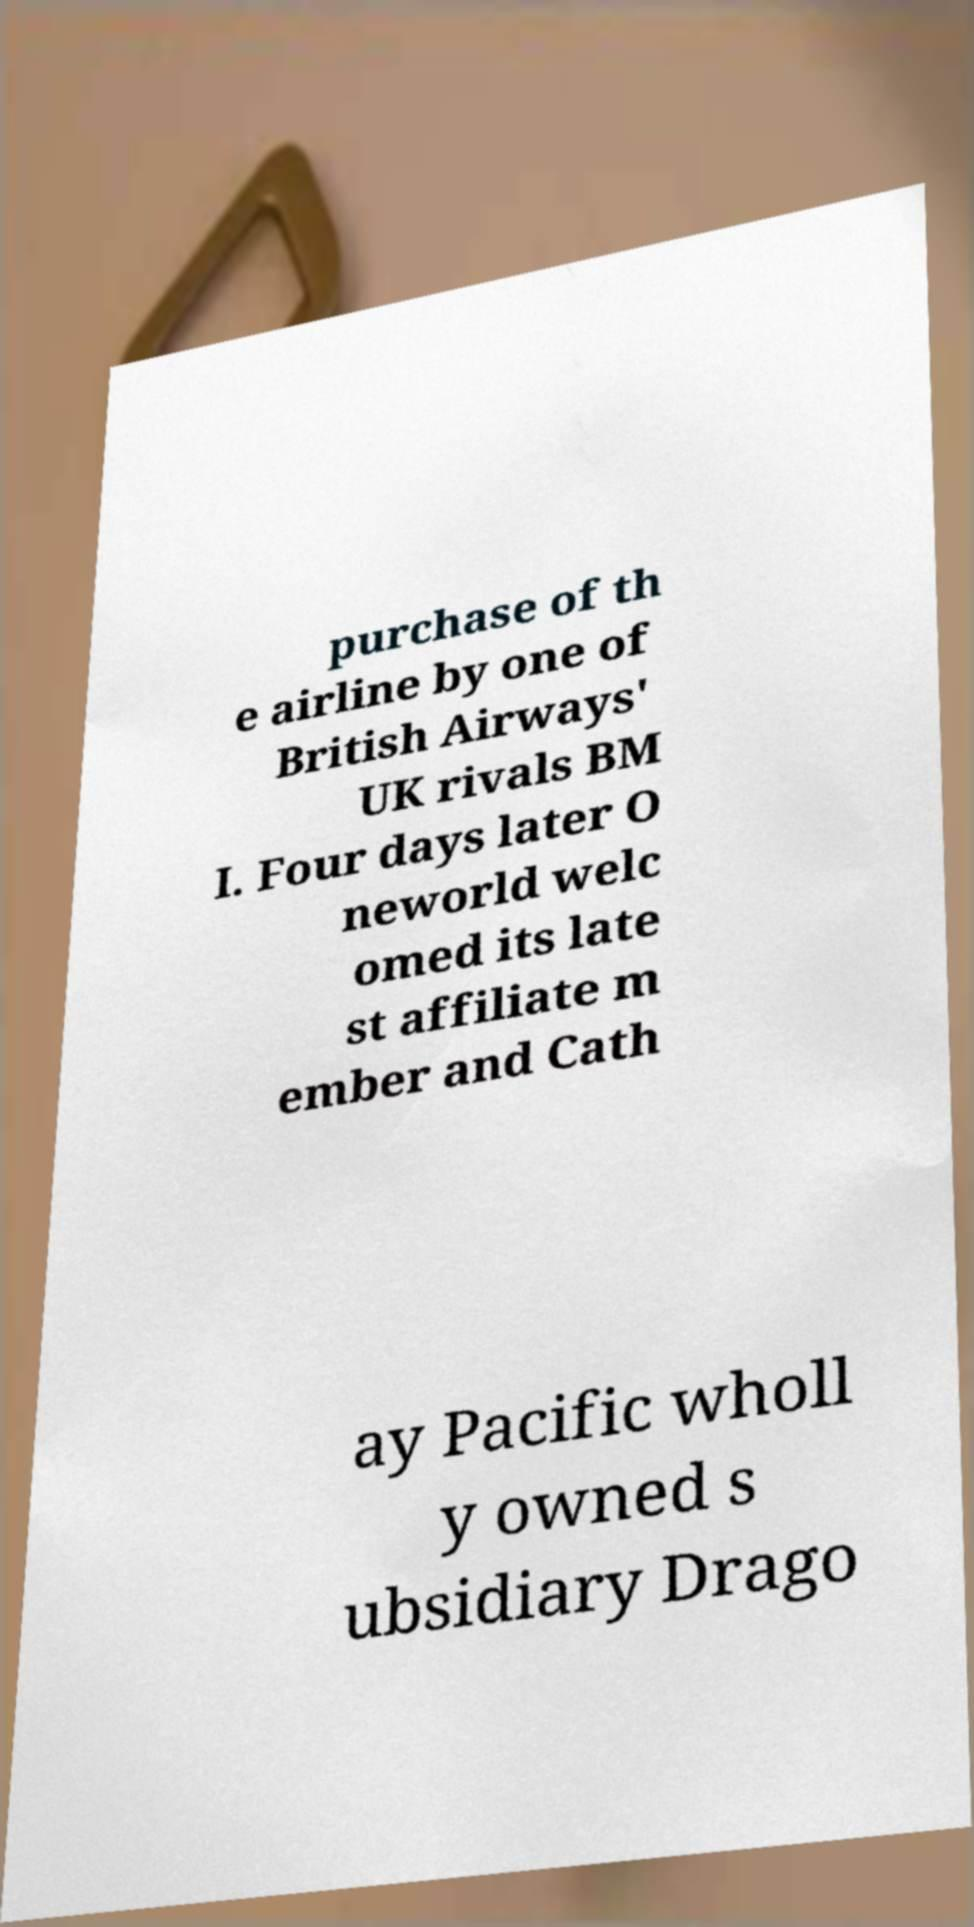Please read and relay the text visible in this image. What does it say? purchase of th e airline by one of British Airways' UK rivals BM I. Four days later O neworld welc omed its late st affiliate m ember and Cath ay Pacific wholl y owned s ubsidiary Drago 